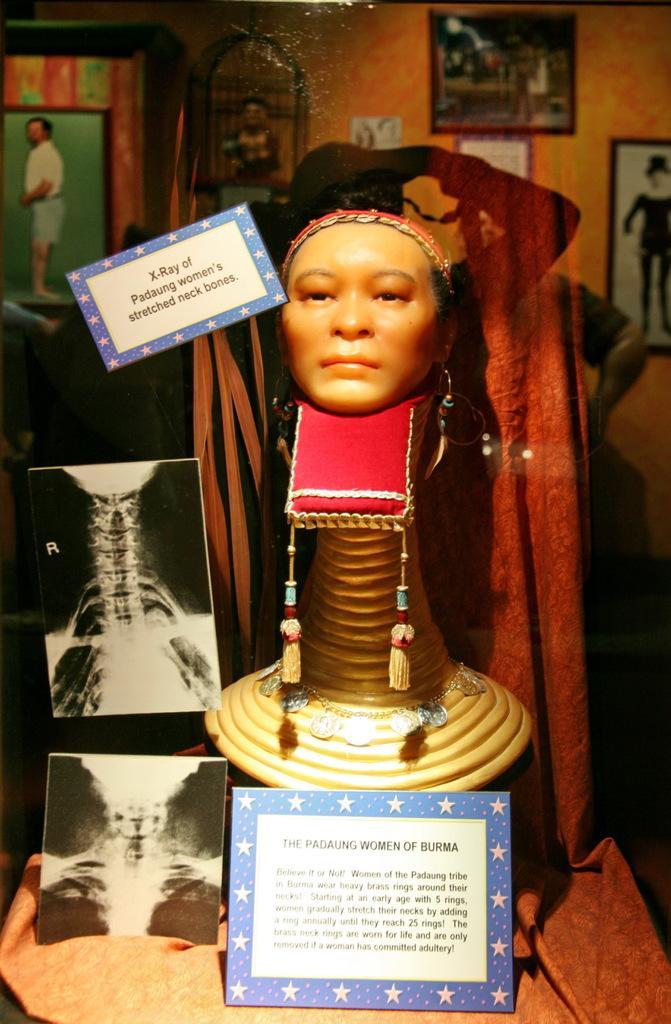How would you summarize this image in a sentence or two? In this image there is a sculpture near to the sculpture there are x-rays and cards on that cards some text is written, in the background there is a wall to that wall there are photos. 